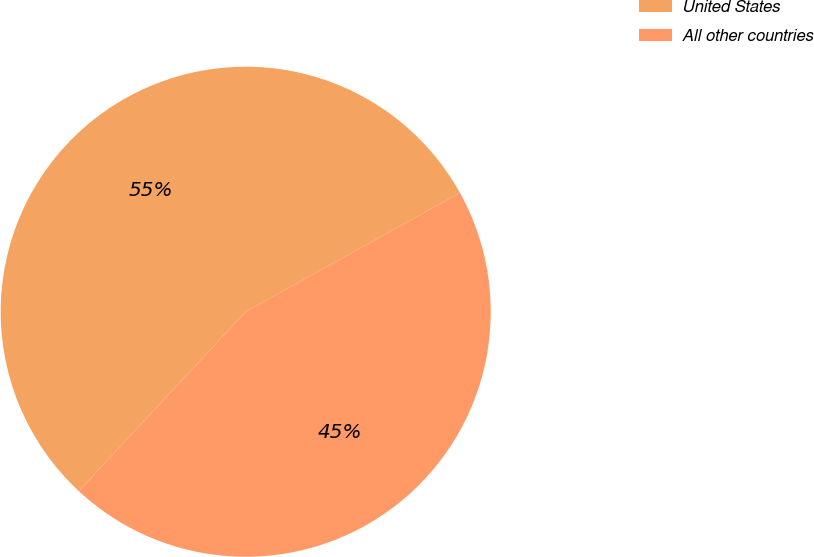Convert chart. <chart><loc_0><loc_0><loc_500><loc_500><pie_chart><fcel>United States<fcel>All other countries<nl><fcel>55.0%<fcel>45.0%<nl></chart> 